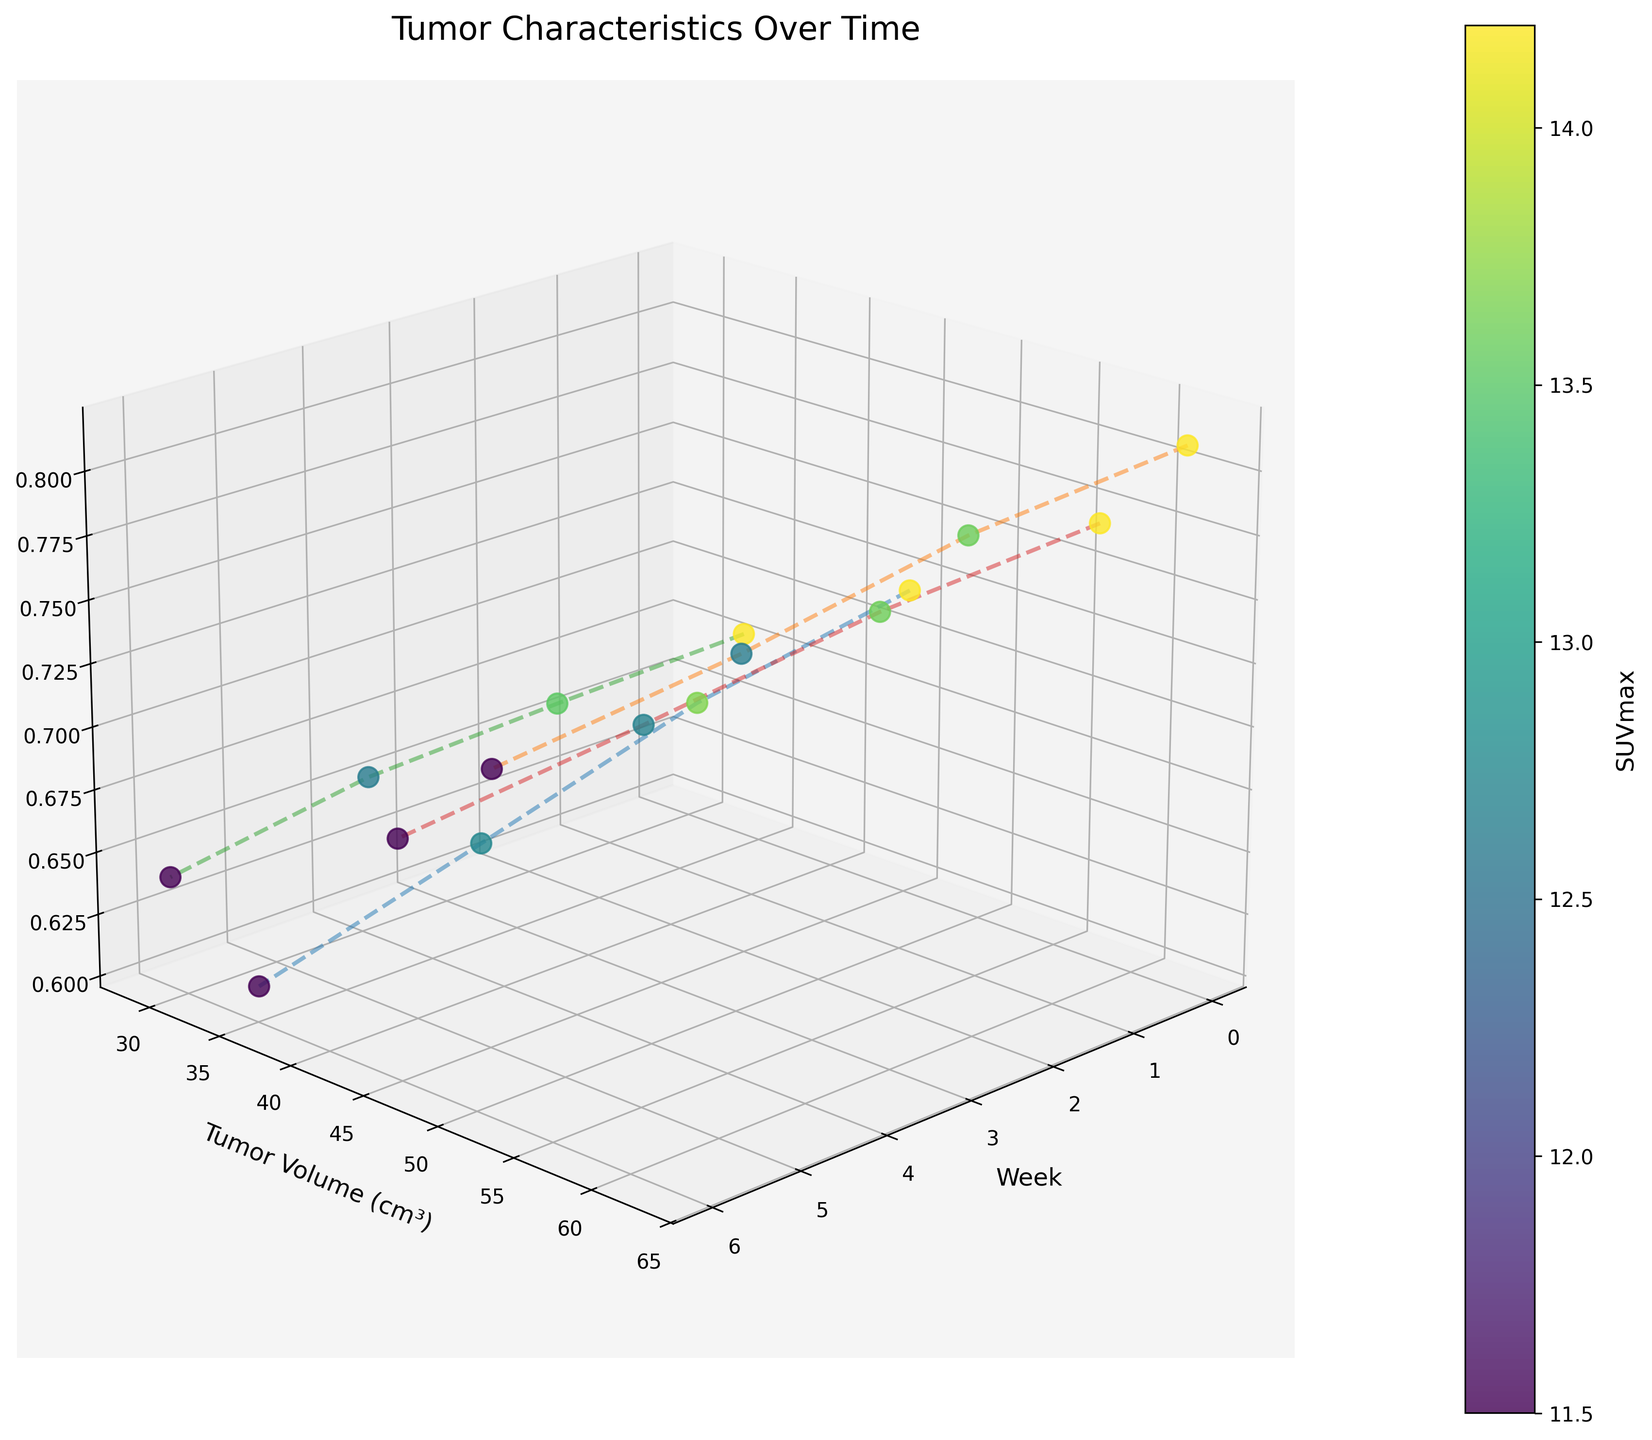Which patient has the highest initial tumor volume? Find the patient data points at Week 0 and compare their Tumor Volume (cm³). The highest initial value is for Patient P002 with 62.7 cm³.
Answer: P002 How does the shape factor of each patient's tumor change over time? Observe the shape factor values for each patient across all weeks. For all patients, the shape factor decreases over time.
Answer: Decreases What is the general trend in SUVmax across all patients? Examine the color of the data points for all patients, starting from Week 0 to Week 6. The color generally shifts to lighter shades, indicating a decrease in SUVmax.
Answer: Decreases Which patient showed the most significant decrease in tumor volume over the study period? Determine the difference between the initial and final tumor volumes for each patient and compare them. P002 shows the most significant decrease from 62.7 to 51.2 cm³, which is a 11.5 cm³ reduction.
Answer: P002 At Week 4, which patient has the smallest tumor volume? Compare the tumor volumes of all patients specifically at Week 4. Patient P003 has the smallest tumor volume of 30.6 cm³ at Week 4.
Answer: P003 What is the SUVmax of Patient P001 at Week 6? Locate Patient P001's data point at Week 6 and read off the SUVmax value. It is 9.7.
Answer: 9.7 Between Patients P001 and P004, who had a greater reduction in shape factor? Calculate the difference in the shape factor from Week 0 to Week 6 for both patients: P001 (0.72-0.61=0.11) and P004 (0.77-0.69=0.08). P001 has a greater reduction.
Answer: P001 During Week 2, which patient has the highest SUVmax? Look at the data points for Week 2 and compare the SUVmax values. Patient P002 has the highest SUVmax of 14.9.
Answer: P002 Does any patient's tumor volume increase at any point during the weeks observed? Examine the tumor volumes week-to-week for each patient. None of the patients show an increase in their tumor volume during the observation period.
Answer: No What is the average decrease in tumor volume for Patient P004 by Week 6? Calculate the initial and final tumor volume for Patient P004, and find the difference (57.4 - 44.9 = 12.5 cm³). The average decrease per week is 12.5 / 6 = approximately 2.08 cm³ per week.
Answer: 2.08 cm³ per week 